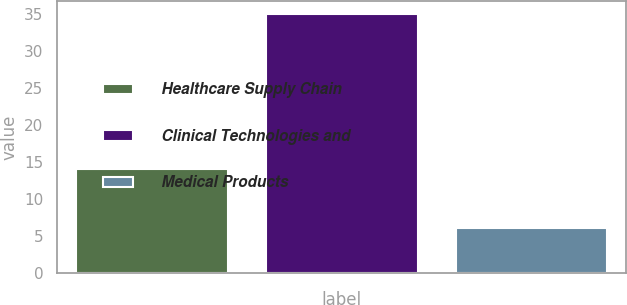Convert chart to OTSL. <chart><loc_0><loc_0><loc_500><loc_500><bar_chart><fcel>Healthcare Supply Chain<fcel>Clinical Technologies and<fcel>Medical Products<nl><fcel>14<fcel>35<fcel>6<nl></chart> 